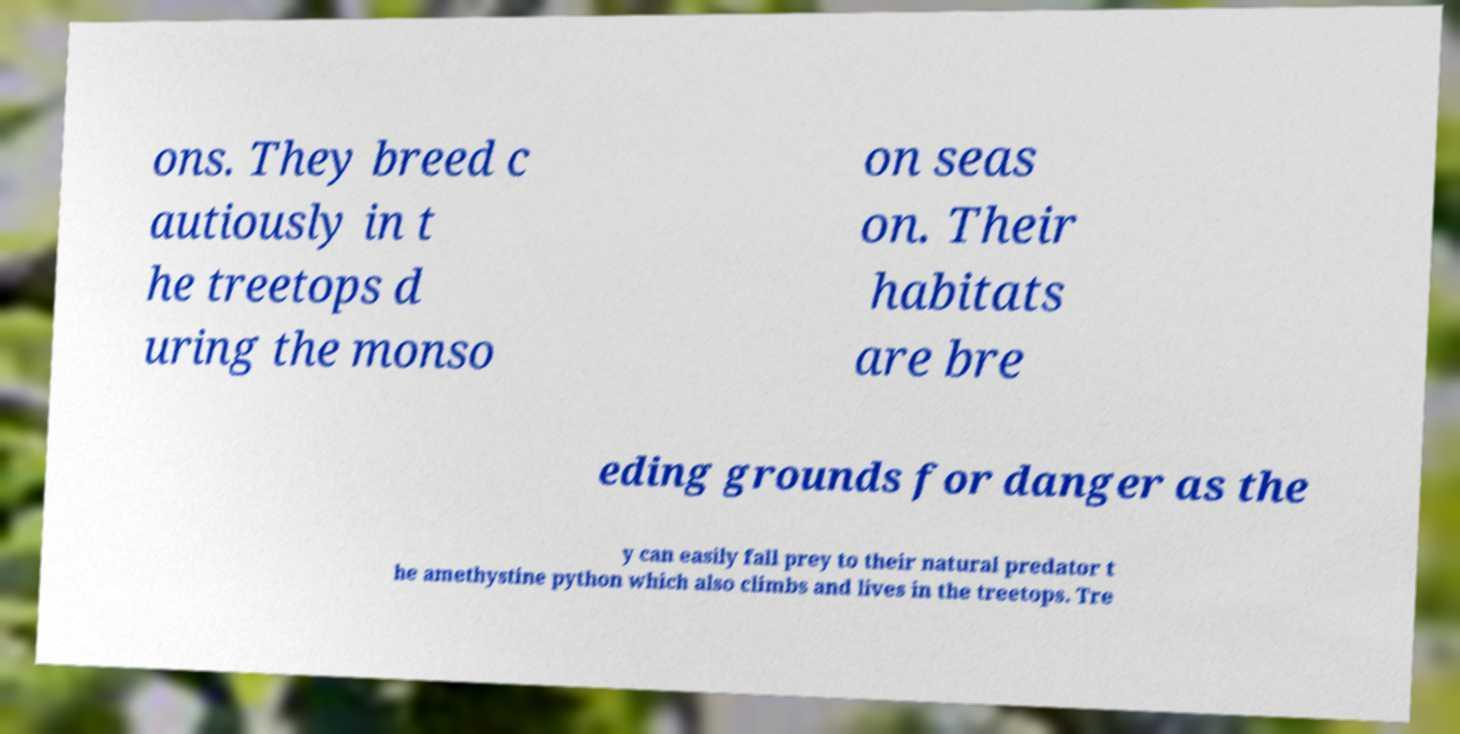Please read and relay the text visible in this image. What does it say? ons. They breed c autiously in t he treetops d uring the monso on seas on. Their habitats are bre eding grounds for danger as the y can easily fall prey to their natural predator t he amethystine python which also climbs and lives in the treetops. Tre 